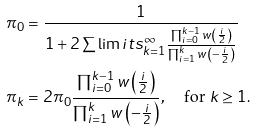Convert formula to latex. <formula><loc_0><loc_0><loc_500><loc_500>\pi _ { 0 } & = \frac { 1 } { 1 + 2 \sum \lim i t s _ { k = 1 } ^ { \infty } { \frac { \prod _ { i = 0 } ^ { k - 1 } { w \left ( \frac { i } { 2 } \right ) } } { \prod _ { i = 1 } ^ { k } { w \left ( - \frac { i } { 2 } \right ) } } } } \\ \pi _ { k } & = 2 \pi _ { 0 } \frac { \prod _ { i = 0 } ^ { k - 1 } { w \left ( \frac { i } { 2 } \right ) } } { \prod _ { i = 1 } ^ { k } { w \left ( - \frac { i } { 2 } \right ) } } , \quad \text {for } k \geq 1 .</formula> 